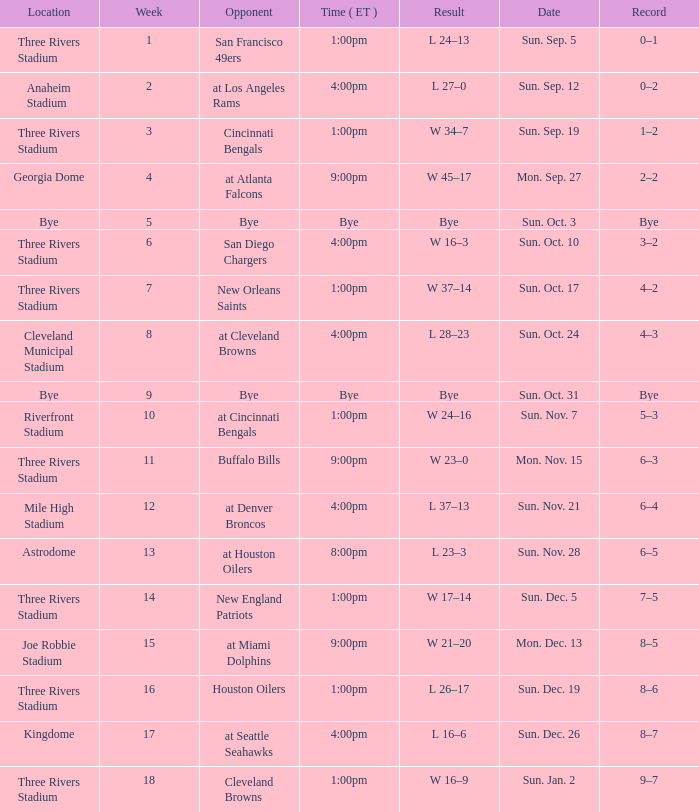What is the earliest week that shows a record of 8–5? 15.0. 